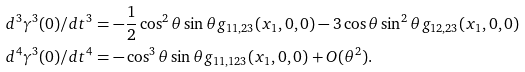<formula> <loc_0><loc_0><loc_500><loc_500>d ^ { 3 } \gamma ^ { 3 } ( 0 ) / d t ^ { 3 } & = - \frac { 1 } { 2 } \cos ^ { 2 } \theta \sin \theta g _ { 1 1 , 2 3 } ( x _ { 1 } , 0 , 0 ) - 3 \cos \theta \sin ^ { 2 } \theta g _ { 1 2 , 2 3 } ( x _ { 1 } , 0 , 0 ) \\ d ^ { 4 } \gamma ^ { 3 } ( 0 ) / d t ^ { 4 } & = - \cos ^ { 3 } \theta \sin \theta g _ { 1 1 , 1 2 3 } ( x _ { 1 } , 0 , 0 ) + O ( \theta ^ { 2 } ) .</formula> 